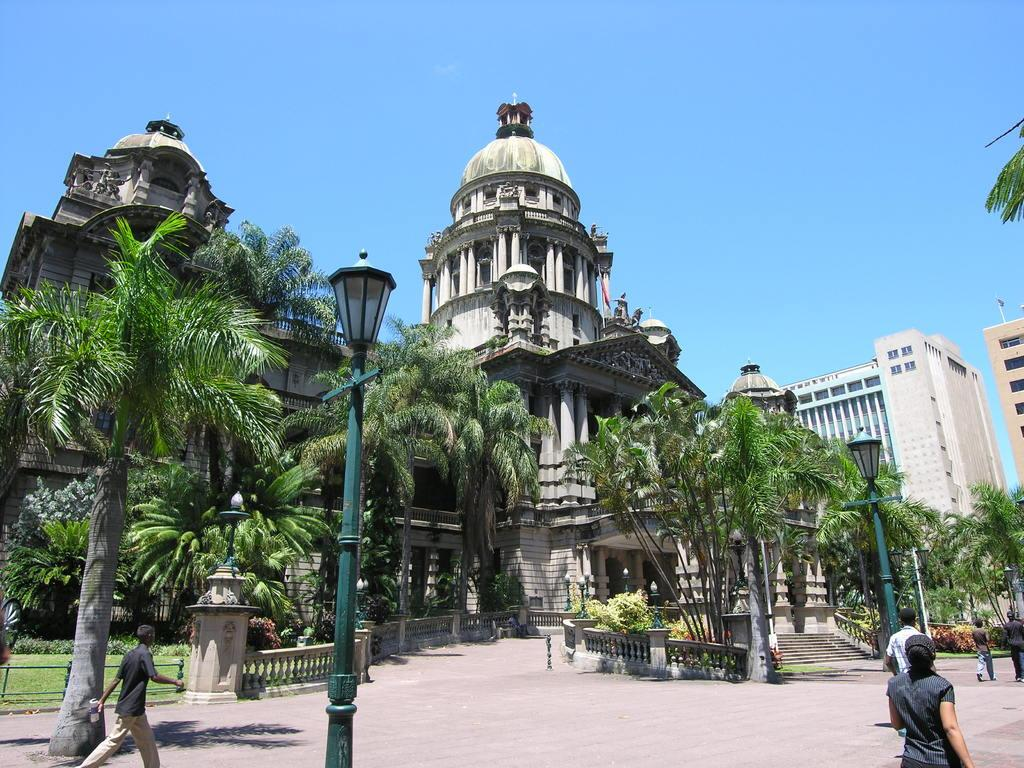How many people are in the image? There are people in the image, but the exact number is not specified. What type of structures can be seen in the image? There are buildings, poles with lights, and pillars in the image. What type of vegetation is present in the image? There are plants, trees, and grass in the image. Can you describe the architectural feature in the image? There is a staircase in the image. What is visible in the background of the image? The sky is visible in the background of the image. What type of crime is being committed in the image? There is no indication of any crime being committed in the image. What is the hope level of the people in the image? There is no information about the hope level of the people in the image. 